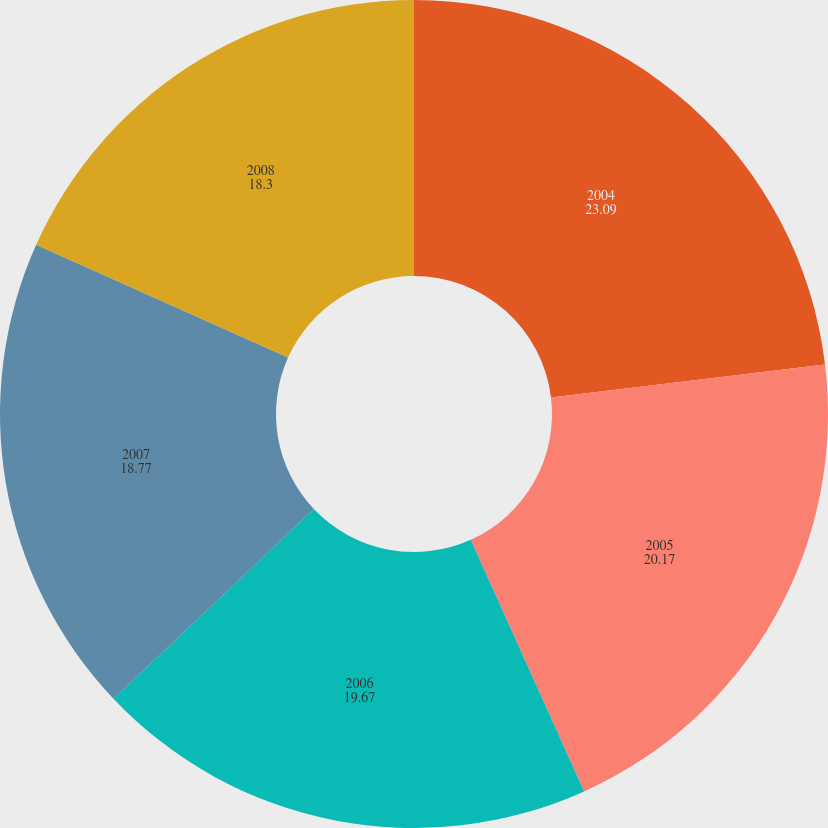Convert chart. <chart><loc_0><loc_0><loc_500><loc_500><pie_chart><fcel>2004<fcel>2005<fcel>2006<fcel>2007<fcel>2008<nl><fcel>23.09%<fcel>20.17%<fcel>19.67%<fcel>18.77%<fcel>18.3%<nl></chart> 